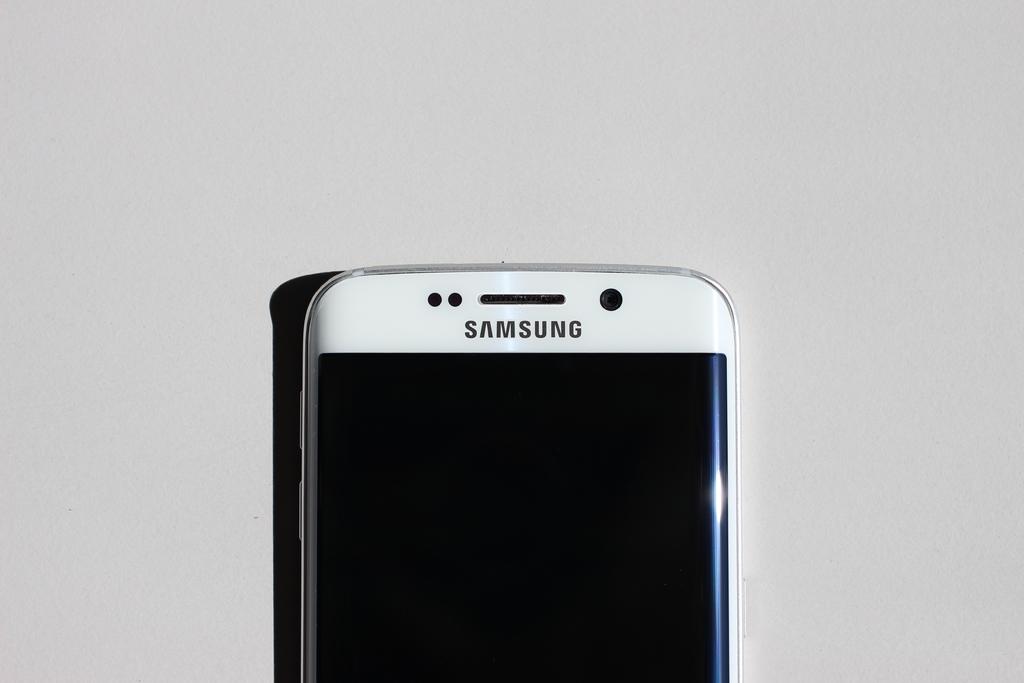What company made this phone?
Your response must be concise. Samsung. 